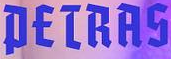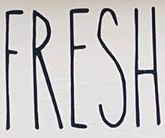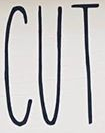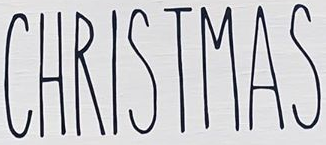What words can you see in these images in sequence, separated by a semicolon? PETRAS; FRESH; CUT; CHRISTMAS 